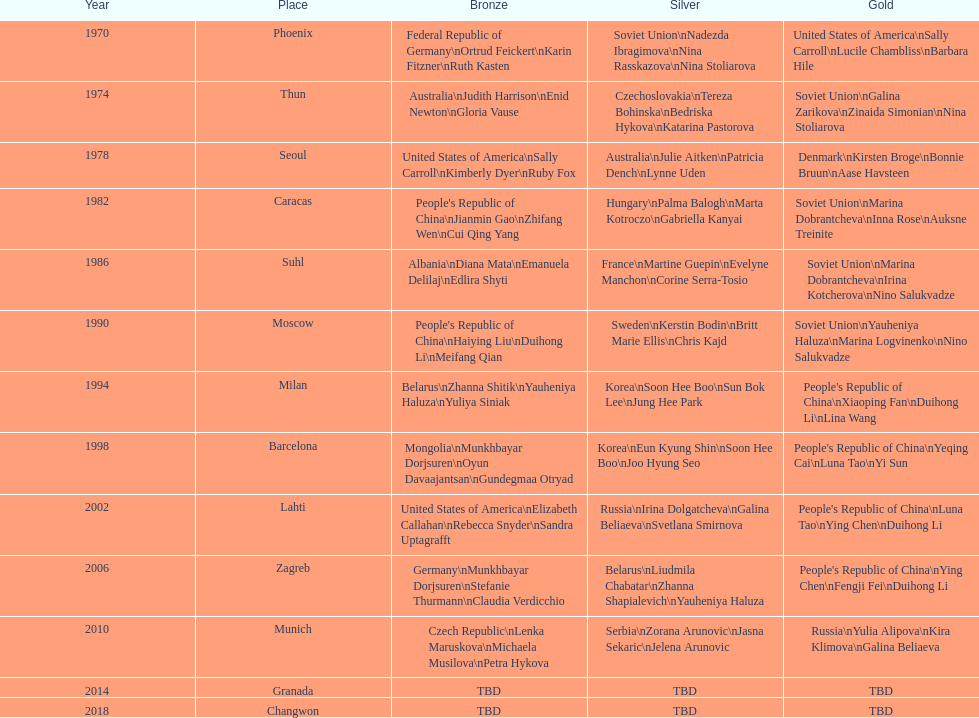What is the first place listed in this chart? Phoenix. 